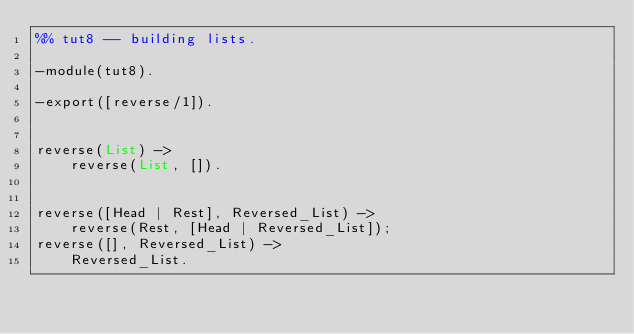<code> <loc_0><loc_0><loc_500><loc_500><_Erlang_>%% tut8 -- building lists.

-module(tut8).

-export([reverse/1]).


reverse(List) ->
    reverse(List, []).


reverse([Head | Rest], Reversed_List) ->
    reverse(Rest, [Head | Reversed_List]);
reverse([], Reversed_List) ->
    Reversed_List.
</code> 